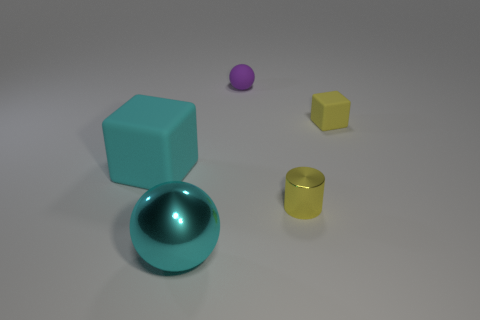Add 1 small purple matte balls. How many objects exist? 6 Subtract all cylinders. How many objects are left? 4 Subtract 0 blue blocks. How many objects are left? 5 Subtract all yellow cylinders. Subtract all big rubber objects. How many objects are left? 3 Add 4 large cyan spheres. How many large cyan spheres are left? 5 Add 1 purple rubber things. How many purple rubber things exist? 2 